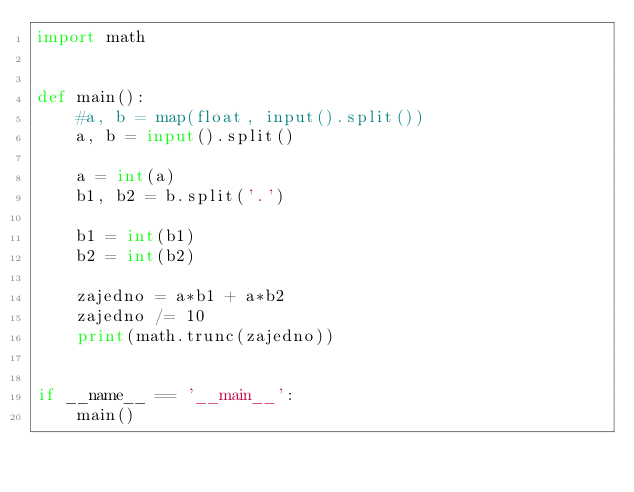Convert code to text. <code><loc_0><loc_0><loc_500><loc_500><_Python_>import math


def main():
    #a, b = map(float, input().split())
    a, b = input().split()

    a = int(a)
    b1, b2 = b.split('.')

    b1 = int(b1)
    b2 = int(b2)

    zajedno = a*b1 + a*b2
    zajedno /= 10
    print(math.trunc(zajedno))


if __name__ == '__main__':
    main()
</code> 